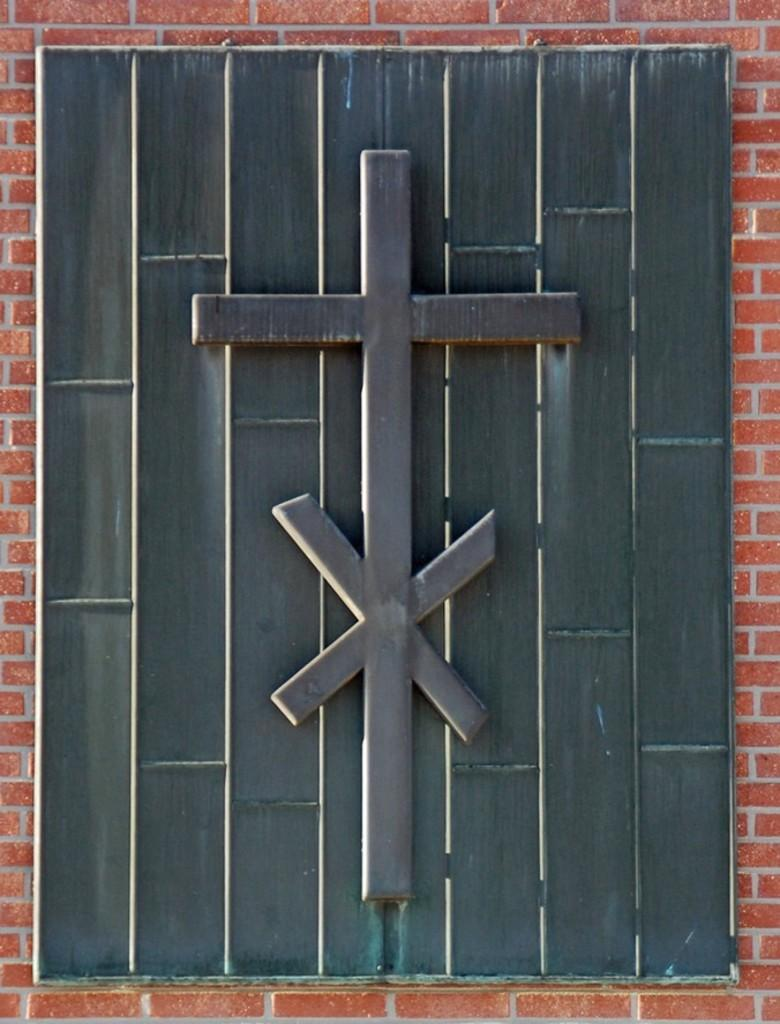What is located in the foreground of the image? There is a window in the foreground of the image. What else can be seen in the image? There is a wall visible in the image. How much does the drum weigh in the image? There is no drum present in the image, so its weight cannot be determined. 